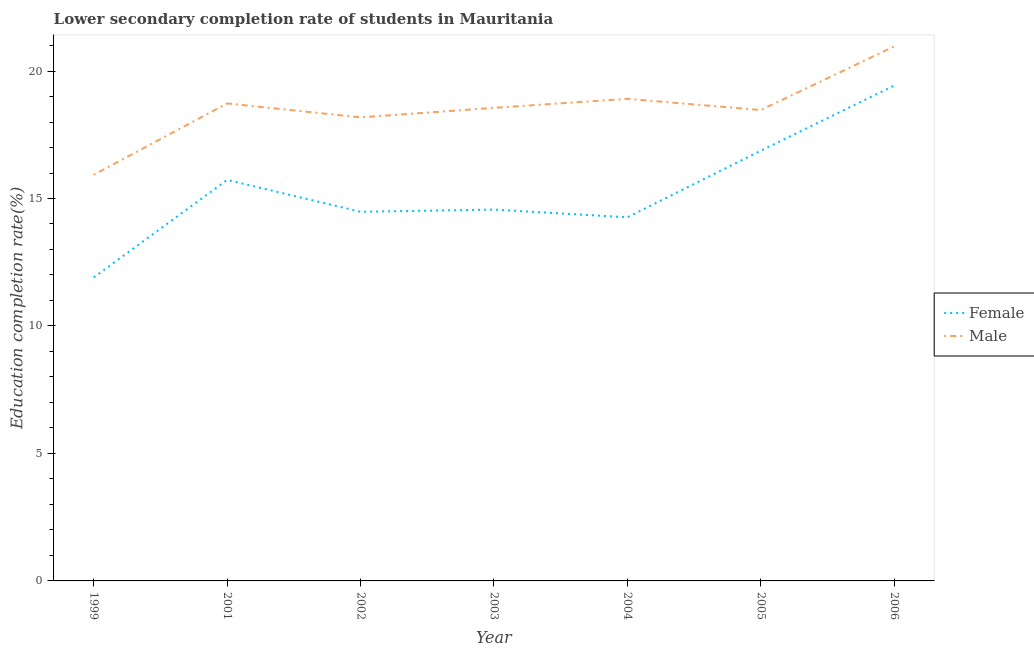How many different coloured lines are there?
Your answer should be compact. 2. Does the line corresponding to education completion rate of female students intersect with the line corresponding to education completion rate of male students?
Provide a short and direct response. No. Is the number of lines equal to the number of legend labels?
Provide a short and direct response. Yes. What is the education completion rate of male students in 2004?
Provide a short and direct response. 18.91. Across all years, what is the maximum education completion rate of male students?
Offer a very short reply. 20.97. Across all years, what is the minimum education completion rate of female students?
Provide a succinct answer. 11.9. In which year was the education completion rate of male students maximum?
Provide a succinct answer. 2006. In which year was the education completion rate of male students minimum?
Your answer should be compact. 1999. What is the total education completion rate of female students in the graph?
Provide a short and direct response. 107.25. What is the difference between the education completion rate of female students in 2004 and that in 2005?
Make the answer very short. -2.61. What is the difference between the education completion rate of male students in 2005 and the education completion rate of female students in 2001?
Your answer should be compact. 2.74. What is the average education completion rate of female students per year?
Your answer should be very brief. 15.32. In the year 2004, what is the difference between the education completion rate of male students and education completion rate of female students?
Your response must be concise. 4.65. What is the ratio of the education completion rate of male students in 2002 to that in 2005?
Offer a very short reply. 0.98. Is the difference between the education completion rate of female students in 1999 and 2003 greater than the difference between the education completion rate of male students in 1999 and 2003?
Provide a short and direct response. No. What is the difference between the highest and the second highest education completion rate of male students?
Make the answer very short. 2.06. What is the difference between the highest and the lowest education completion rate of male students?
Offer a very short reply. 5.03. In how many years, is the education completion rate of male students greater than the average education completion rate of male students taken over all years?
Your response must be concise. 4. Is the sum of the education completion rate of female students in 2003 and 2005 greater than the maximum education completion rate of male students across all years?
Your response must be concise. Yes. Does the education completion rate of female students monotonically increase over the years?
Give a very brief answer. No. Is the education completion rate of female students strictly greater than the education completion rate of male students over the years?
Your answer should be compact. No. How many lines are there?
Your answer should be compact. 2. Are the values on the major ticks of Y-axis written in scientific E-notation?
Your answer should be very brief. No. Does the graph contain any zero values?
Offer a very short reply. No. Where does the legend appear in the graph?
Offer a terse response. Center right. How many legend labels are there?
Make the answer very short. 2. What is the title of the graph?
Offer a terse response. Lower secondary completion rate of students in Mauritania. Does "Under-five" appear as one of the legend labels in the graph?
Make the answer very short. No. What is the label or title of the X-axis?
Provide a succinct answer. Year. What is the label or title of the Y-axis?
Make the answer very short. Education completion rate(%). What is the Education completion rate(%) of Female in 1999?
Your answer should be compact. 11.9. What is the Education completion rate(%) in Male in 1999?
Ensure brevity in your answer.  15.93. What is the Education completion rate(%) in Female in 2001?
Your answer should be very brief. 15.73. What is the Education completion rate(%) of Male in 2001?
Provide a succinct answer. 18.73. What is the Education completion rate(%) in Female in 2002?
Keep it short and to the point. 14.48. What is the Education completion rate(%) in Male in 2002?
Your response must be concise. 18.18. What is the Education completion rate(%) of Female in 2003?
Make the answer very short. 14.57. What is the Education completion rate(%) of Male in 2003?
Keep it short and to the point. 18.56. What is the Education completion rate(%) of Female in 2004?
Keep it short and to the point. 14.26. What is the Education completion rate(%) in Male in 2004?
Ensure brevity in your answer.  18.91. What is the Education completion rate(%) in Female in 2005?
Your response must be concise. 16.88. What is the Education completion rate(%) of Male in 2005?
Offer a terse response. 18.47. What is the Education completion rate(%) of Female in 2006?
Your answer should be compact. 19.43. What is the Education completion rate(%) in Male in 2006?
Keep it short and to the point. 20.97. Across all years, what is the maximum Education completion rate(%) of Female?
Offer a very short reply. 19.43. Across all years, what is the maximum Education completion rate(%) in Male?
Keep it short and to the point. 20.97. Across all years, what is the minimum Education completion rate(%) in Female?
Make the answer very short. 11.9. Across all years, what is the minimum Education completion rate(%) of Male?
Offer a terse response. 15.93. What is the total Education completion rate(%) of Female in the graph?
Offer a very short reply. 107.25. What is the total Education completion rate(%) of Male in the graph?
Ensure brevity in your answer.  129.74. What is the difference between the Education completion rate(%) of Female in 1999 and that in 2001?
Give a very brief answer. -3.83. What is the difference between the Education completion rate(%) of Male in 1999 and that in 2001?
Your answer should be very brief. -2.8. What is the difference between the Education completion rate(%) in Female in 1999 and that in 2002?
Provide a short and direct response. -2.58. What is the difference between the Education completion rate(%) in Male in 1999 and that in 2002?
Make the answer very short. -2.25. What is the difference between the Education completion rate(%) in Female in 1999 and that in 2003?
Provide a succinct answer. -2.66. What is the difference between the Education completion rate(%) in Male in 1999 and that in 2003?
Keep it short and to the point. -2.63. What is the difference between the Education completion rate(%) in Female in 1999 and that in 2004?
Make the answer very short. -2.36. What is the difference between the Education completion rate(%) of Male in 1999 and that in 2004?
Offer a terse response. -2.98. What is the difference between the Education completion rate(%) in Female in 1999 and that in 2005?
Ensure brevity in your answer.  -4.97. What is the difference between the Education completion rate(%) in Male in 1999 and that in 2005?
Your response must be concise. -2.54. What is the difference between the Education completion rate(%) in Female in 1999 and that in 2006?
Give a very brief answer. -7.53. What is the difference between the Education completion rate(%) in Male in 1999 and that in 2006?
Make the answer very short. -5.03. What is the difference between the Education completion rate(%) of Female in 2001 and that in 2002?
Ensure brevity in your answer.  1.25. What is the difference between the Education completion rate(%) of Male in 2001 and that in 2002?
Offer a very short reply. 0.55. What is the difference between the Education completion rate(%) in Female in 2001 and that in 2003?
Your response must be concise. 1.16. What is the difference between the Education completion rate(%) in Male in 2001 and that in 2003?
Give a very brief answer. 0.17. What is the difference between the Education completion rate(%) in Female in 2001 and that in 2004?
Your answer should be compact. 1.47. What is the difference between the Education completion rate(%) of Male in 2001 and that in 2004?
Offer a very short reply. -0.18. What is the difference between the Education completion rate(%) in Female in 2001 and that in 2005?
Your response must be concise. -1.15. What is the difference between the Education completion rate(%) in Male in 2001 and that in 2005?
Keep it short and to the point. 0.26. What is the difference between the Education completion rate(%) of Female in 2001 and that in 2006?
Your answer should be compact. -3.7. What is the difference between the Education completion rate(%) of Male in 2001 and that in 2006?
Ensure brevity in your answer.  -2.24. What is the difference between the Education completion rate(%) in Female in 2002 and that in 2003?
Provide a short and direct response. -0.09. What is the difference between the Education completion rate(%) of Male in 2002 and that in 2003?
Ensure brevity in your answer.  -0.37. What is the difference between the Education completion rate(%) in Female in 2002 and that in 2004?
Offer a terse response. 0.22. What is the difference between the Education completion rate(%) of Male in 2002 and that in 2004?
Your answer should be compact. -0.73. What is the difference between the Education completion rate(%) in Female in 2002 and that in 2005?
Give a very brief answer. -2.4. What is the difference between the Education completion rate(%) of Male in 2002 and that in 2005?
Keep it short and to the point. -0.29. What is the difference between the Education completion rate(%) of Female in 2002 and that in 2006?
Keep it short and to the point. -4.95. What is the difference between the Education completion rate(%) of Male in 2002 and that in 2006?
Your answer should be very brief. -2.78. What is the difference between the Education completion rate(%) in Female in 2003 and that in 2004?
Provide a succinct answer. 0.3. What is the difference between the Education completion rate(%) in Male in 2003 and that in 2004?
Provide a short and direct response. -0.35. What is the difference between the Education completion rate(%) of Female in 2003 and that in 2005?
Give a very brief answer. -2.31. What is the difference between the Education completion rate(%) in Male in 2003 and that in 2005?
Your answer should be very brief. 0.09. What is the difference between the Education completion rate(%) of Female in 2003 and that in 2006?
Keep it short and to the point. -4.86. What is the difference between the Education completion rate(%) of Male in 2003 and that in 2006?
Your response must be concise. -2.41. What is the difference between the Education completion rate(%) of Female in 2004 and that in 2005?
Your response must be concise. -2.61. What is the difference between the Education completion rate(%) in Male in 2004 and that in 2005?
Provide a succinct answer. 0.44. What is the difference between the Education completion rate(%) in Female in 2004 and that in 2006?
Offer a terse response. -5.17. What is the difference between the Education completion rate(%) in Male in 2004 and that in 2006?
Offer a very short reply. -2.06. What is the difference between the Education completion rate(%) of Female in 2005 and that in 2006?
Make the answer very short. -2.55. What is the difference between the Education completion rate(%) of Male in 2005 and that in 2006?
Your answer should be very brief. -2.5. What is the difference between the Education completion rate(%) in Female in 1999 and the Education completion rate(%) in Male in 2001?
Your answer should be compact. -6.83. What is the difference between the Education completion rate(%) of Female in 1999 and the Education completion rate(%) of Male in 2002?
Keep it short and to the point. -6.28. What is the difference between the Education completion rate(%) of Female in 1999 and the Education completion rate(%) of Male in 2003?
Provide a succinct answer. -6.65. What is the difference between the Education completion rate(%) of Female in 1999 and the Education completion rate(%) of Male in 2004?
Your response must be concise. -7.01. What is the difference between the Education completion rate(%) in Female in 1999 and the Education completion rate(%) in Male in 2005?
Your answer should be compact. -6.57. What is the difference between the Education completion rate(%) in Female in 1999 and the Education completion rate(%) in Male in 2006?
Ensure brevity in your answer.  -9.06. What is the difference between the Education completion rate(%) in Female in 2001 and the Education completion rate(%) in Male in 2002?
Offer a terse response. -2.45. What is the difference between the Education completion rate(%) of Female in 2001 and the Education completion rate(%) of Male in 2003?
Provide a succinct answer. -2.83. What is the difference between the Education completion rate(%) of Female in 2001 and the Education completion rate(%) of Male in 2004?
Your answer should be very brief. -3.18. What is the difference between the Education completion rate(%) in Female in 2001 and the Education completion rate(%) in Male in 2005?
Keep it short and to the point. -2.74. What is the difference between the Education completion rate(%) of Female in 2001 and the Education completion rate(%) of Male in 2006?
Your answer should be compact. -5.24. What is the difference between the Education completion rate(%) of Female in 2002 and the Education completion rate(%) of Male in 2003?
Provide a succinct answer. -4.08. What is the difference between the Education completion rate(%) in Female in 2002 and the Education completion rate(%) in Male in 2004?
Provide a succinct answer. -4.43. What is the difference between the Education completion rate(%) of Female in 2002 and the Education completion rate(%) of Male in 2005?
Provide a short and direct response. -3.99. What is the difference between the Education completion rate(%) of Female in 2002 and the Education completion rate(%) of Male in 2006?
Make the answer very short. -6.49. What is the difference between the Education completion rate(%) in Female in 2003 and the Education completion rate(%) in Male in 2004?
Offer a terse response. -4.34. What is the difference between the Education completion rate(%) in Female in 2003 and the Education completion rate(%) in Male in 2005?
Ensure brevity in your answer.  -3.9. What is the difference between the Education completion rate(%) in Female in 2003 and the Education completion rate(%) in Male in 2006?
Provide a succinct answer. -6.4. What is the difference between the Education completion rate(%) in Female in 2004 and the Education completion rate(%) in Male in 2005?
Provide a short and direct response. -4.21. What is the difference between the Education completion rate(%) in Female in 2004 and the Education completion rate(%) in Male in 2006?
Your response must be concise. -6.7. What is the difference between the Education completion rate(%) of Female in 2005 and the Education completion rate(%) of Male in 2006?
Your answer should be very brief. -4.09. What is the average Education completion rate(%) in Female per year?
Your response must be concise. 15.32. What is the average Education completion rate(%) of Male per year?
Your answer should be very brief. 18.53. In the year 1999, what is the difference between the Education completion rate(%) in Female and Education completion rate(%) in Male?
Your answer should be very brief. -4.03. In the year 2001, what is the difference between the Education completion rate(%) of Female and Education completion rate(%) of Male?
Provide a short and direct response. -3. In the year 2002, what is the difference between the Education completion rate(%) of Female and Education completion rate(%) of Male?
Your response must be concise. -3.7. In the year 2003, what is the difference between the Education completion rate(%) in Female and Education completion rate(%) in Male?
Offer a terse response. -3.99. In the year 2004, what is the difference between the Education completion rate(%) of Female and Education completion rate(%) of Male?
Provide a short and direct response. -4.65. In the year 2005, what is the difference between the Education completion rate(%) of Female and Education completion rate(%) of Male?
Offer a very short reply. -1.59. In the year 2006, what is the difference between the Education completion rate(%) in Female and Education completion rate(%) in Male?
Ensure brevity in your answer.  -1.54. What is the ratio of the Education completion rate(%) of Female in 1999 to that in 2001?
Your answer should be compact. 0.76. What is the ratio of the Education completion rate(%) in Male in 1999 to that in 2001?
Provide a succinct answer. 0.85. What is the ratio of the Education completion rate(%) in Female in 1999 to that in 2002?
Make the answer very short. 0.82. What is the ratio of the Education completion rate(%) of Male in 1999 to that in 2002?
Ensure brevity in your answer.  0.88. What is the ratio of the Education completion rate(%) in Female in 1999 to that in 2003?
Provide a succinct answer. 0.82. What is the ratio of the Education completion rate(%) in Male in 1999 to that in 2003?
Keep it short and to the point. 0.86. What is the ratio of the Education completion rate(%) in Female in 1999 to that in 2004?
Keep it short and to the point. 0.83. What is the ratio of the Education completion rate(%) in Male in 1999 to that in 2004?
Make the answer very short. 0.84. What is the ratio of the Education completion rate(%) of Female in 1999 to that in 2005?
Ensure brevity in your answer.  0.71. What is the ratio of the Education completion rate(%) in Male in 1999 to that in 2005?
Offer a very short reply. 0.86. What is the ratio of the Education completion rate(%) of Female in 1999 to that in 2006?
Keep it short and to the point. 0.61. What is the ratio of the Education completion rate(%) of Male in 1999 to that in 2006?
Offer a very short reply. 0.76. What is the ratio of the Education completion rate(%) of Female in 2001 to that in 2002?
Give a very brief answer. 1.09. What is the ratio of the Education completion rate(%) of Male in 2001 to that in 2002?
Give a very brief answer. 1.03. What is the ratio of the Education completion rate(%) of Female in 2001 to that in 2003?
Your response must be concise. 1.08. What is the ratio of the Education completion rate(%) in Male in 2001 to that in 2003?
Provide a succinct answer. 1.01. What is the ratio of the Education completion rate(%) of Female in 2001 to that in 2004?
Ensure brevity in your answer.  1.1. What is the ratio of the Education completion rate(%) of Female in 2001 to that in 2005?
Ensure brevity in your answer.  0.93. What is the ratio of the Education completion rate(%) of Male in 2001 to that in 2005?
Keep it short and to the point. 1.01. What is the ratio of the Education completion rate(%) of Female in 2001 to that in 2006?
Provide a short and direct response. 0.81. What is the ratio of the Education completion rate(%) in Male in 2001 to that in 2006?
Ensure brevity in your answer.  0.89. What is the ratio of the Education completion rate(%) in Male in 2002 to that in 2003?
Make the answer very short. 0.98. What is the ratio of the Education completion rate(%) in Female in 2002 to that in 2004?
Keep it short and to the point. 1.02. What is the ratio of the Education completion rate(%) in Male in 2002 to that in 2004?
Provide a succinct answer. 0.96. What is the ratio of the Education completion rate(%) of Female in 2002 to that in 2005?
Your answer should be very brief. 0.86. What is the ratio of the Education completion rate(%) in Male in 2002 to that in 2005?
Your answer should be compact. 0.98. What is the ratio of the Education completion rate(%) in Female in 2002 to that in 2006?
Ensure brevity in your answer.  0.75. What is the ratio of the Education completion rate(%) in Male in 2002 to that in 2006?
Your answer should be very brief. 0.87. What is the ratio of the Education completion rate(%) of Female in 2003 to that in 2004?
Give a very brief answer. 1.02. What is the ratio of the Education completion rate(%) of Male in 2003 to that in 2004?
Make the answer very short. 0.98. What is the ratio of the Education completion rate(%) of Female in 2003 to that in 2005?
Ensure brevity in your answer.  0.86. What is the ratio of the Education completion rate(%) in Male in 2003 to that in 2005?
Keep it short and to the point. 1. What is the ratio of the Education completion rate(%) in Female in 2003 to that in 2006?
Ensure brevity in your answer.  0.75. What is the ratio of the Education completion rate(%) in Male in 2003 to that in 2006?
Your answer should be compact. 0.89. What is the ratio of the Education completion rate(%) in Female in 2004 to that in 2005?
Provide a short and direct response. 0.85. What is the ratio of the Education completion rate(%) in Male in 2004 to that in 2005?
Offer a terse response. 1.02. What is the ratio of the Education completion rate(%) of Female in 2004 to that in 2006?
Your answer should be very brief. 0.73. What is the ratio of the Education completion rate(%) of Male in 2004 to that in 2006?
Keep it short and to the point. 0.9. What is the ratio of the Education completion rate(%) of Female in 2005 to that in 2006?
Provide a short and direct response. 0.87. What is the ratio of the Education completion rate(%) of Male in 2005 to that in 2006?
Make the answer very short. 0.88. What is the difference between the highest and the second highest Education completion rate(%) in Female?
Your answer should be compact. 2.55. What is the difference between the highest and the second highest Education completion rate(%) of Male?
Your response must be concise. 2.06. What is the difference between the highest and the lowest Education completion rate(%) in Female?
Offer a very short reply. 7.53. What is the difference between the highest and the lowest Education completion rate(%) of Male?
Your answer should be very brief. 5.03. 